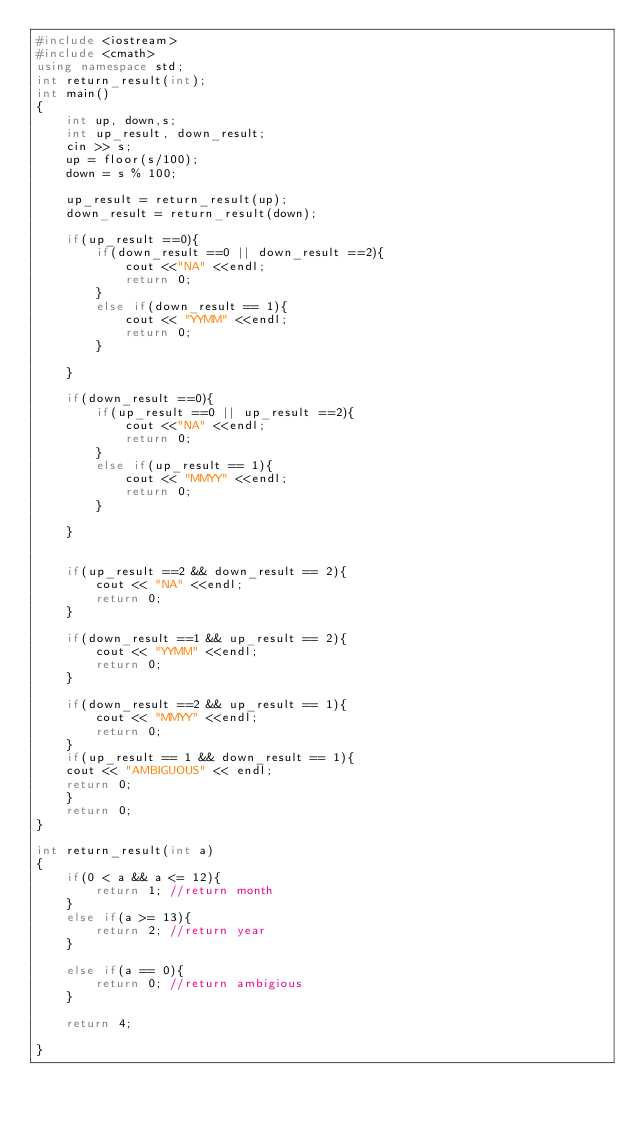Convert code to text. <code><loc_0><loc_0><loc_500><loc_500><_C++_>#include <iostream>
#include <cmath>
using namespace std;
int return_result(int);
int main()
{
    int up, down,s;
    int up_result, down_result;
    cin >> s;
    up = floor(s/100);
    down = s % 100;
    
    up_result = return_result(up);
    down_result = return_result(down);

    if(up_result ==0){
        if(down_result ==0 || down_result ==2){
            cout <<"NA" <<endl;
            return 0;
        }
        else if(down_result == 1){
            cout << "YYMM" <<endl;
            return 0;            
        }

    }

    if(down_result ==0){
        if(up_result ==0 || up_result ==2){
            cout <<"NA" <<endl;
            return 0;
        }
        else if(up_result == 1){
            cout << "MMYY" <<endl;
            return 0;            
        }

    }    


    if(up_result ==2 && down_result == 2){
        cout << "NA" <<endl;
        return 0;
    }

    if(down_result ==1 && up_result == 2){
        cout << "YYMM" <<endl;
        return 0;
    }

    if(down_result ==2 && up_result == 1){
        cout << "MMYY" <<endl;
        return 0;
    }
    if(up_result == 1 && down_result == 1){
    cout << "AMBIGUOUS" << endl;
    return 0;
    }
    return 0;
}

int return_result(int a)
{
    if(0 < a && a <= 12){
        return 1; //return month
    }
    else if(a >= 13){
        return 2; //return year
    }

    else if(a == 0){
        return 0; //return ambigious
    }

    return 4;

}</code> 